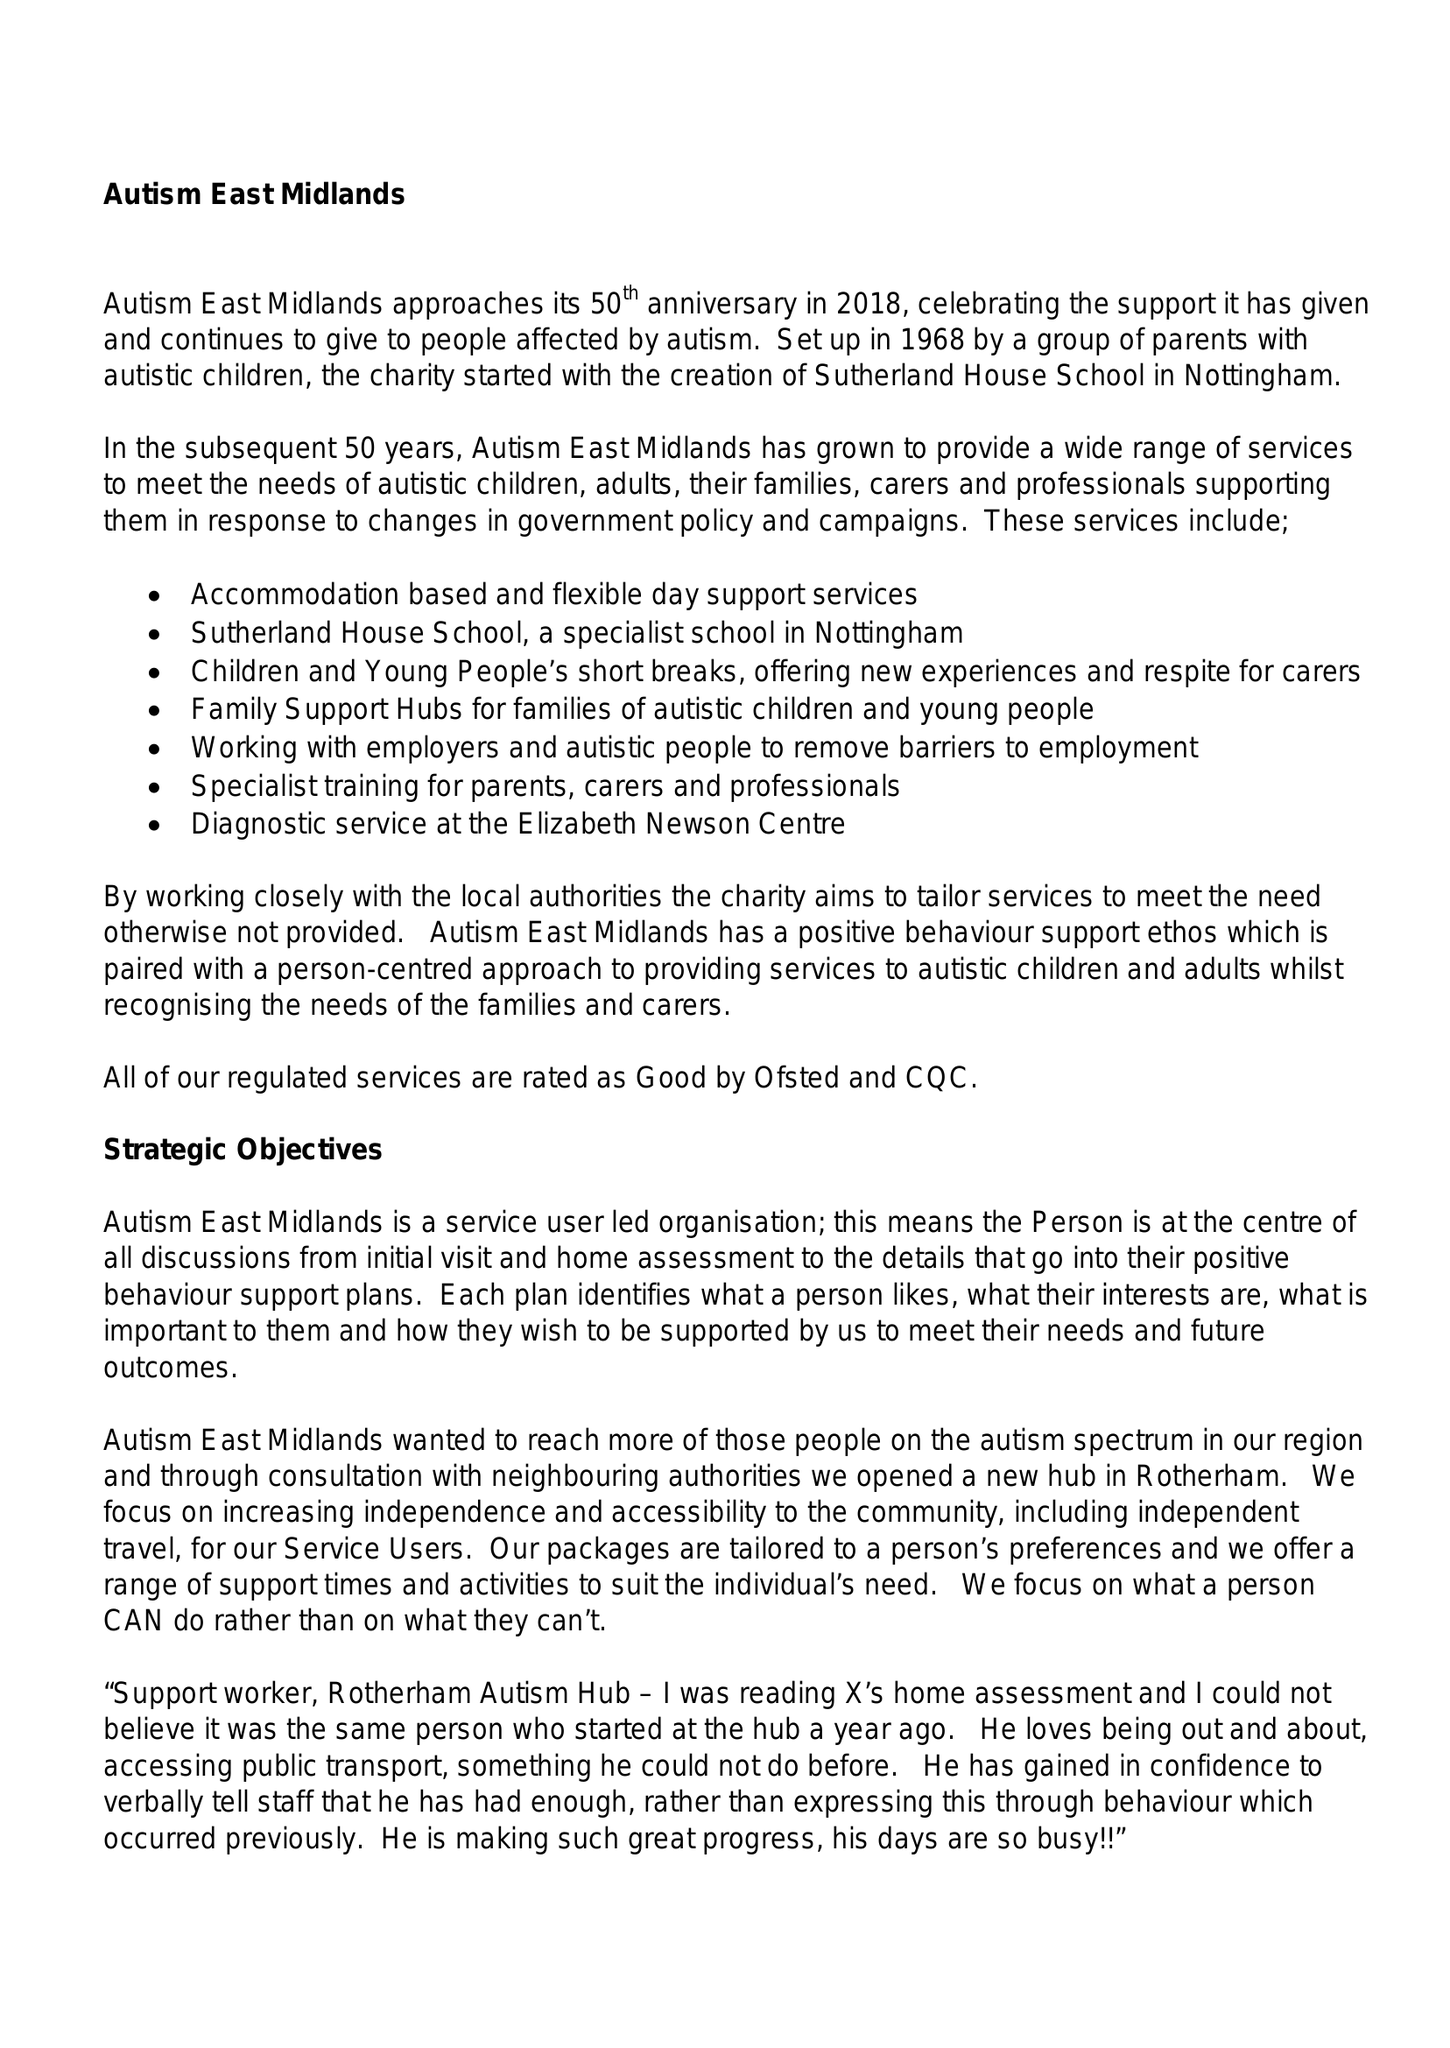What is the value for the report_date?
Answer the question using a single word or phrase. 2018-03-31 